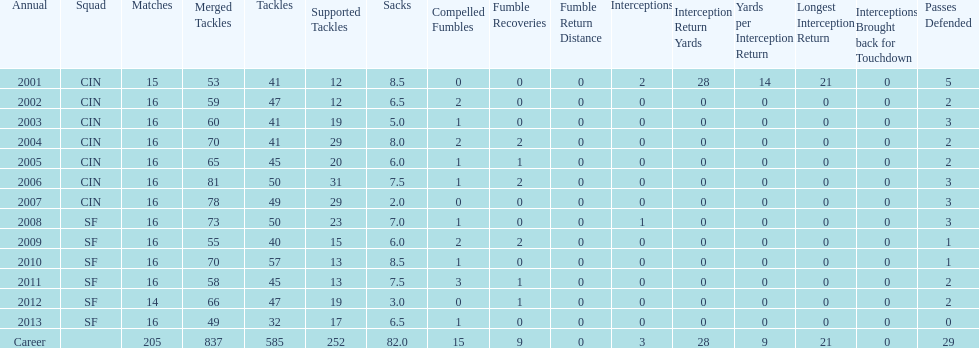How many years did he play in less than 16 games? 2. 